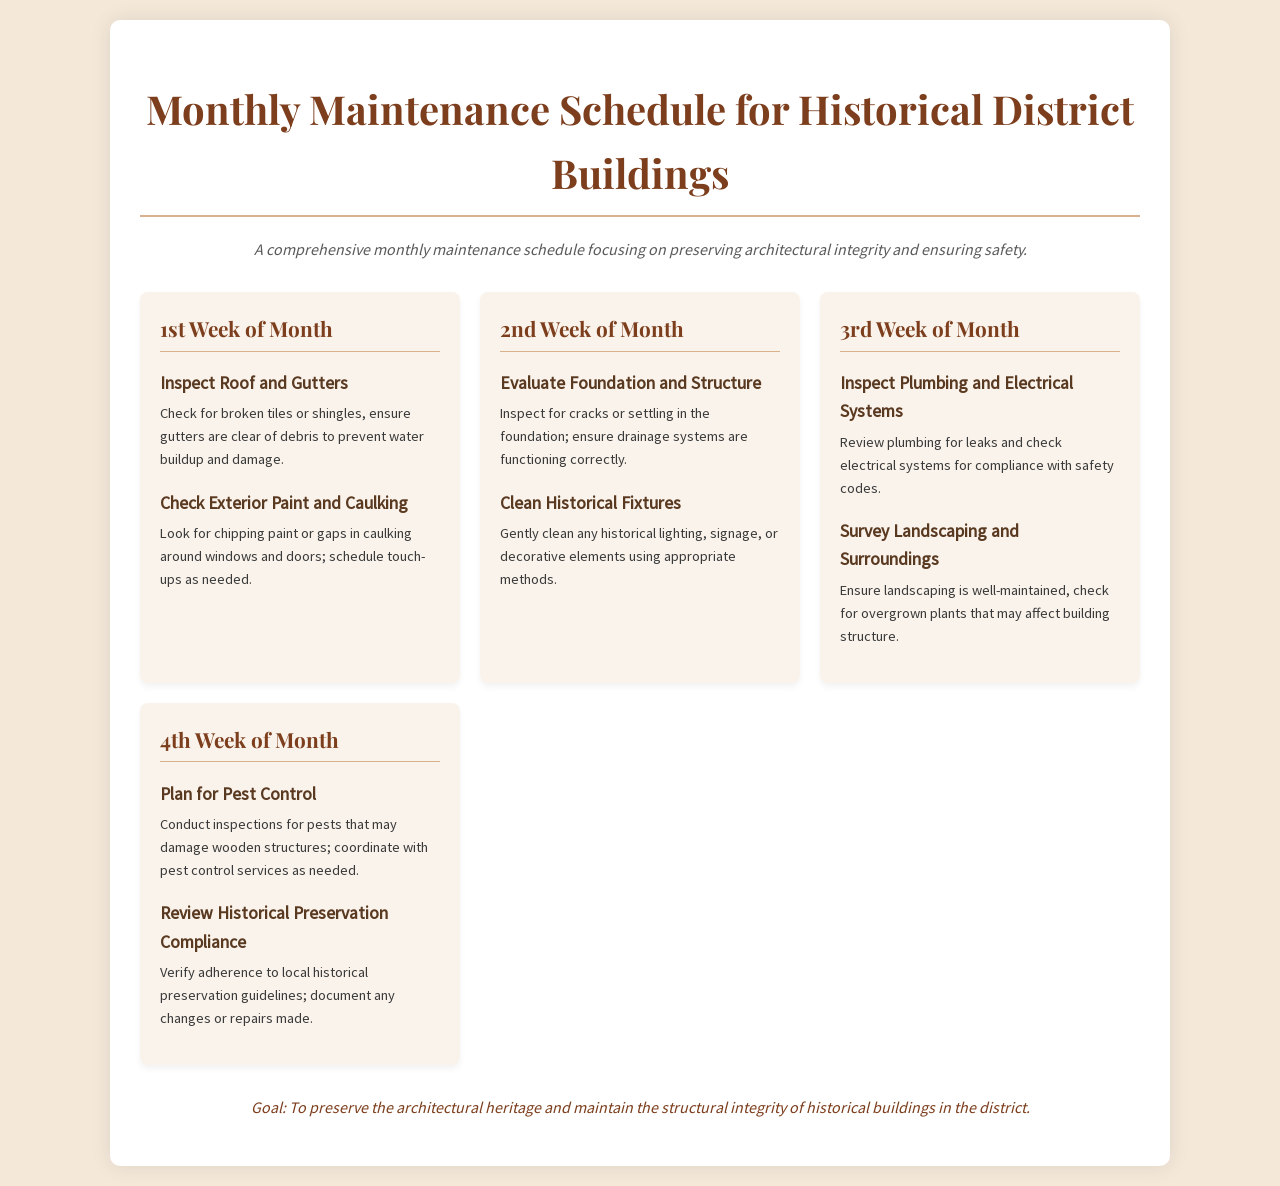What is the first maintenance task for the month? The first maintenance task listed is "Inspect Roof and Gutters," which is scheduled for the 1st week of the month.
Answer: Inspect Roof and Gutters How many tasks are scheduled in the 3rd week? The 3rd week contains two tasks: "Inspect Plumbing and Electrical Systems" and "Survey Landscaping and Surroundings."
Answer: 2 What do the dates of task reviews emphasize? The review of tasks emphasizes monthly inspections and maintenance to preserve historical buildings.
Answer: Monthly What is the main goal of the maintenance schedule? The goal of the schedule is to "preserve the architectural heritage and maintain the structural integrity of historical buildings in the district."
Answer: Preserve architectural heritage Which week focuses on the foundation and structure assessment? The evaluation of the foundation and structure is scheduled for the 2nd week of the month.
Answer: 2nd Week What should be checked regarding pest control? The schedule indicates that there should be inspections for pests that may damage wooden structures during the 4th week.
Answer: Inspections for pests 